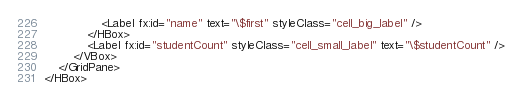Convert code to text. <code><loc_0><loc_0><loc_500><loc_500><_XML_>                <Label fx:id="name" text="\$first" styleClass="cell_big_label" />
            </HBox>
            <Label fx:id="studentCount" styleClass="cell_small_label" text="\$studentCount" />
        </VBox>
    </GridPane>
</HBox>
</code> 